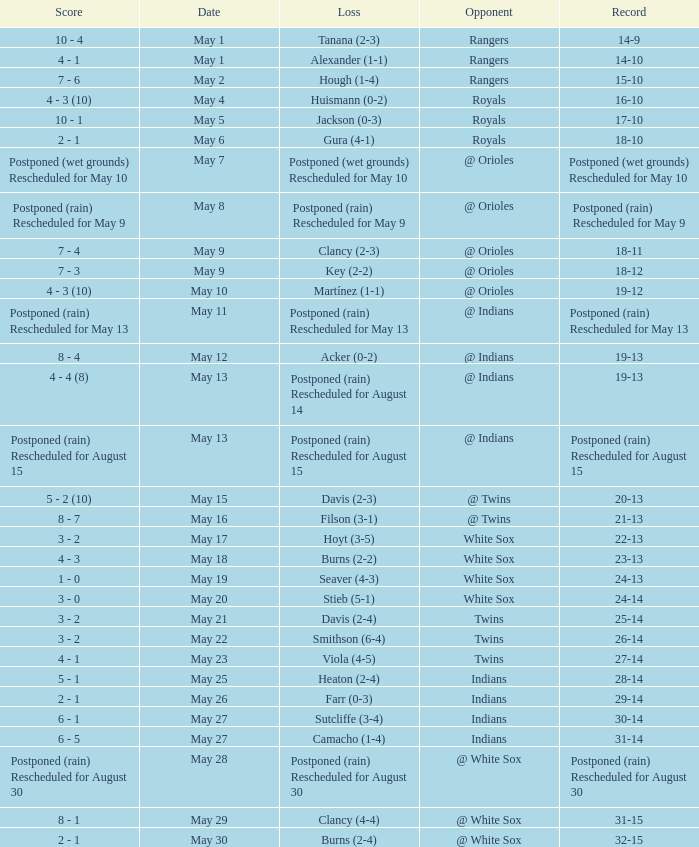What was date of the game when the record was 31-15? May 29. 